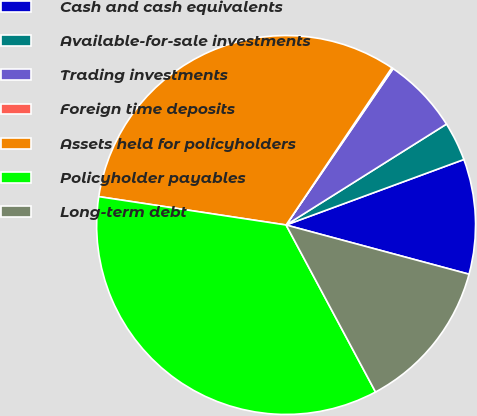Convert chart to OTSL. <chart><loc_0><loc_0><loc_500><loc_500><pie_chart><fcel>Cash and cash equivalents<fcel>Available-for-sale investments<fcel>Trading investments<fcel>Foreign time deposits<fcel>Assets held for policyholders<fcel>Policyholder payables<fcel>Long-term debt<nl><fcel>9.8%<fcel>3.32%<fcel>6.51%<fcel>0.13%<fcel>32.03%<fcel>35.22%<fcel>12.99%<nl></chart> 